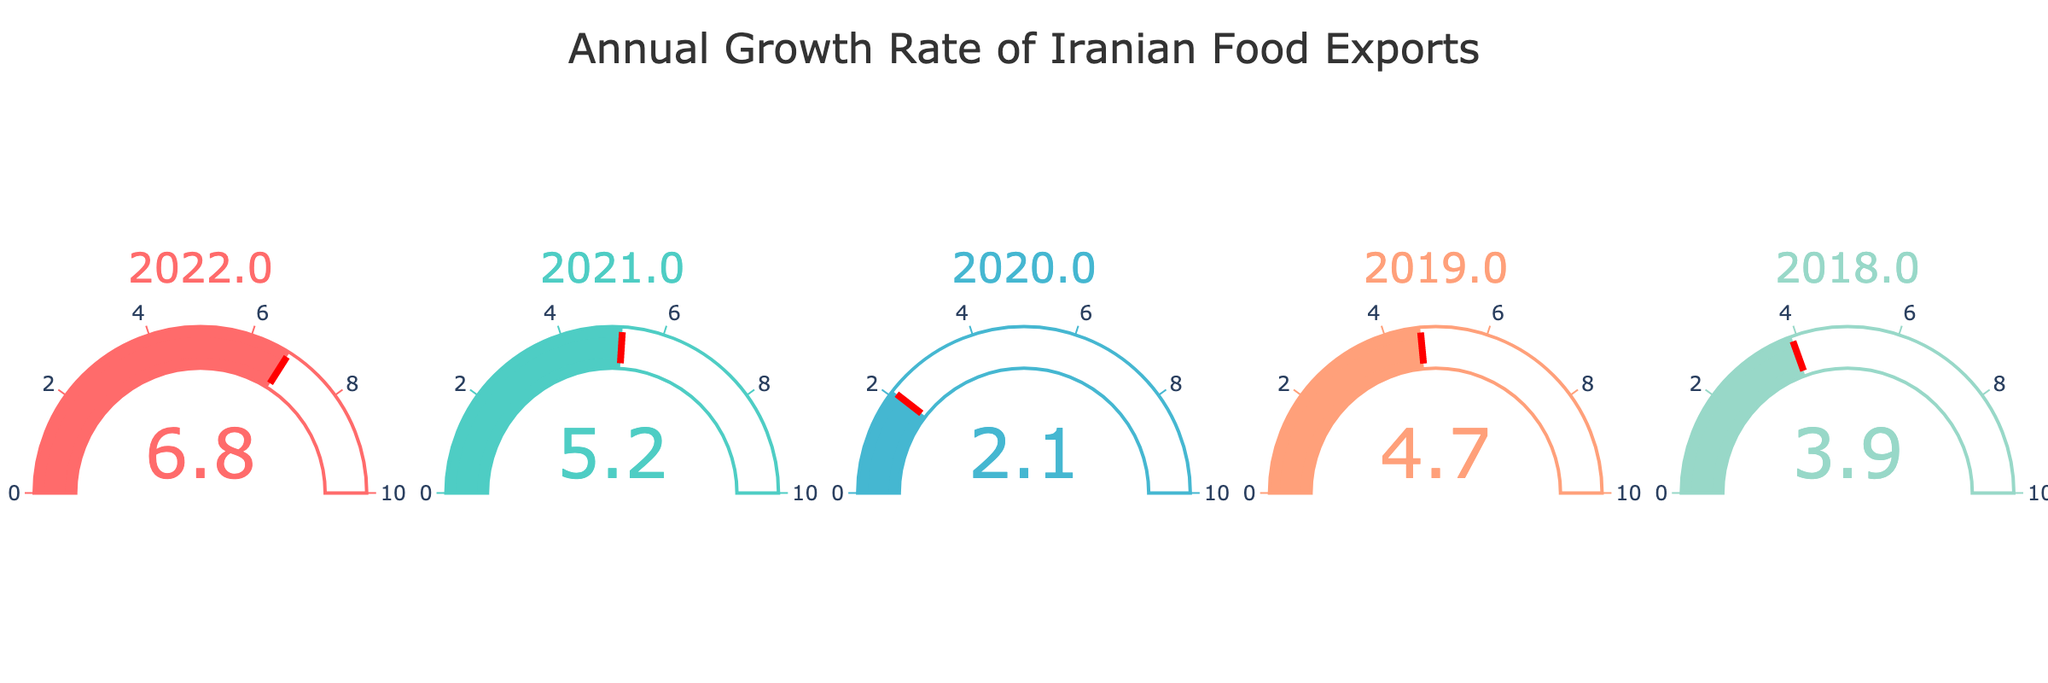What is the title of the figure? The title is displayed at the top of the figure and is clearly visible.
Answer: Annual Growth Rate of Iranian Food Exports How many years are represented in the gauge charts? Each gauge chart represents a different year, and by counting the charts, we can see there are five.
Answer: 5 Which year had the highest annual growth rate in Iranian food exports? By looking at the values in each gauge chart, the highest value is 6.8%, representing the year 2022.
Answer: 2022 Compare the annual growth rates of 2021 and 2020. Which year had a higher rate and by how much? The growth rate for 2021 is 5.2%, while for 2020 it is 2.1%. The difference is 5.2% - 2.1% = 3.1%.
Answer: 2021 by 3.1% What is the average annual growth rate for the years displayed? The values are 6.8%, 5.2%, 2.1%, 4.7%, and 3.9%. Adding them gives 22.7%. Dividing by 5, the average is 22.7% / 5 = 4.54%.
Answer: 4.54% Which year had a lower annual growth rate: 2019 or 2018, and what is the difference? The growth rate for 2019 is 4.7%, and for 2018 it is 3.9%. The difference is 4.7% - 3.9% = 0.8%.
Answer: 2018 by 0.8% Identify the year with the second highest annual growth rate. Sorting the values, the second highest after 6.8% is 5.2%, which corresponds to the year 2021.
Answer: 2021 What range is used on the gauge axes? Each gauge chart's axis is labeled with tick marks, showing a range of 0 to 10.
Answer: 0 to 10 Estimate the median annual growth rate of the years displayed. Listing the values as 6.8%, 5.2%, 4.7%, 3.9%, and 2.1%, the median (middle value) is 4.7%.
Answer: 4.7% What color is used to represent the growth rate for the year 2022? By observing the gauge chart for 2022, the color used is distinguishable and appears as a shade of red.
Answer: Red 